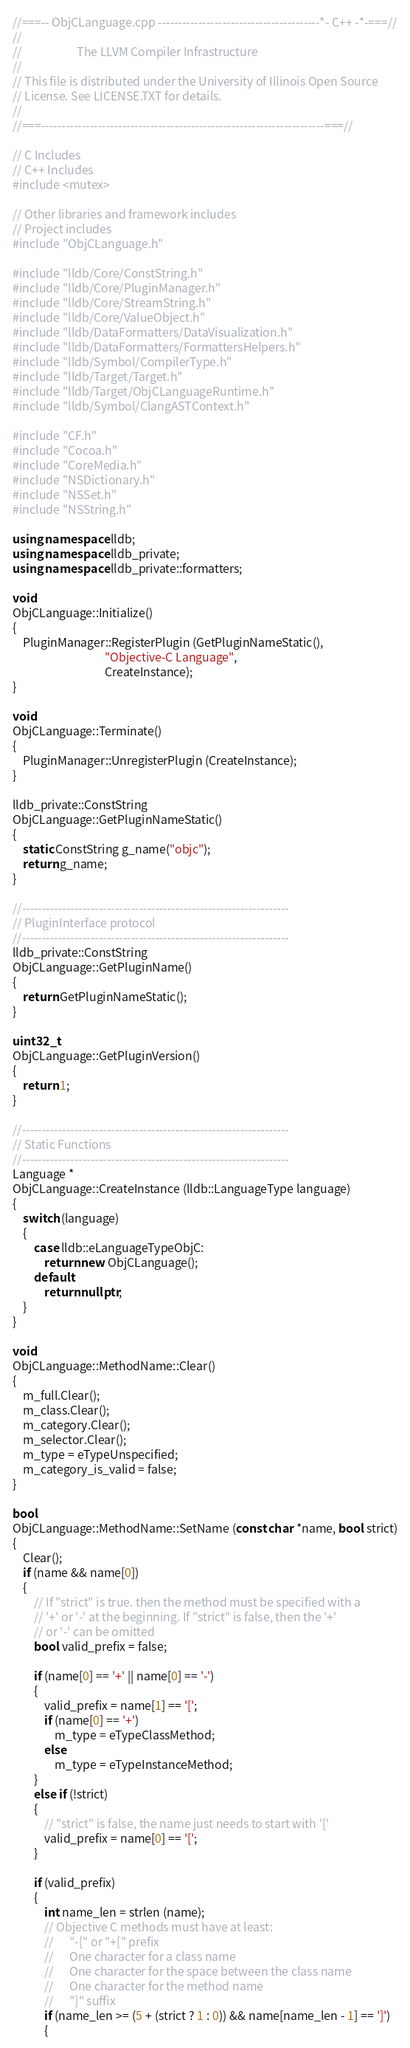Convert code to text. <code><loc_0><loc_0><loc_500><loc_500><_C++_>//===-- ObjCLanguage.cpp ----------------------------------------*- C++ -*-===//
//
//                     The LLVM Compiler Infrastructure
//
// This file is distributed under the University of Illinois Open Source
// License. See LICENSE.TXT for details.
//
//===----------------------------------------------------------------------===//

// C Includes
// C++ Includes
#include <mutex>

// Other libraries and framework includes
// Project includes
#include "ObjCLanguage.h"

#include "lldb/Core/ConstString.h"
#include "lldb/Core/PluginManager.h"
#include "lldb/Core/StreamString.h"
#include "lldb/Core/ValueObject.h"
#include "lldb/DataFormatters/DataVisualization.h"
#include "lldb/DataFormatters/FormattersHelpers.h"
#include "lldb/Symbol/CompilerType.h"
#include "lldb/Target/Target.h"
#include "lldb/Target/ObjCLanguageRuntime.h"
#include "lldb/Symbol/ClangASTContext.h"

#include "CF.h"
#include "Cocoa.h"
#include "CoreMedia.h"
#include "NSDictionary.h"
#include "NSSet.h"
#include "NSString.h"

using namespace lldb;
using namespace lldb_private;
using namespace lldb_private::formatters;

void
ObjCLanguage::Initialize()
{
    PluginManager::RegisterPlugin (GetPluginNameStatic(),
                                   "Objective-C Language",
                                   CreateInstance);
}

void
ObjCLanguage::Terminate()
{
    PluginManager::UnregisterPlugin (CreateInstance);
}

lldb_private::ConstString
ObjCLanguage::GetPluginNameStatic()
{
    static ConstString g_name("objc");
    return g_name;
}

//------------------------------------------------------------------
// PluginInterface protocol
//------------------------------------------------------------------
lldb_private::ConstString
ObjCLanguage::GetPluginName()
{
    return GetPluginNameStatic();
}

uint32_t
ObjCLanguage::GetPluginVersion()
{
    return 1;
}

//------------------------------------------------------------------
// Static Functions
//------------------------------------------------------------------
Language *
ObjCLanguage::CreateInstance (lldb::LanguageType language)
{
    switch (language)
    {
        case lldb::eLanguageTypeObjC:
            return new ObjCLanguage();
        default:
            return nullptr;
    }
}

void
ObjCLanguage::MethodName::Clear()
{
    m_full.Clear();
    m_class.Clear();
    m_category.Clear();
    m_selector.Clear();
    m_type = eTypeUnspecified;
    m_category_is_valid = false;
}

bool
ObjCLanguage::MethodName::SetName (const char *name, bool strict)
{
    Clear();
    if (name && name[0])
    {
        // If "strict" is true. then the method must be specified with a
        // '+' or '-' at the beginning. If "strict" is false, then the '+'
        // or '-' can be omitted
        bool valid_prefix = false;
        
        if (name[0] == '+' || name[0] == '-')
        {
            valid_prefix = name[1] == '[';
            if (name[0] == '+')
                m_type = eTypeClassMethod;
            else
                m_type = eTypeInstanceMethod;
        }
        else if (!strict)
        {
            // "strict" is false, the name just needs to start with '['
            valid_prefix = name[0] == '[';
        }
        
        if (valid_prefix)
        {
            int name_len = strlen (name);
            // Objective C methods must have at least:
            //      "-[" or "+[" prefix
            //      One character for a class name
            //      One character for the space between the class name
            //      One character for the method name
            //      "]" suffix
            if (name_len >= (5 + (strict ? 1 : 0)) && name[name_len - 1] == ']')
            {</code> 